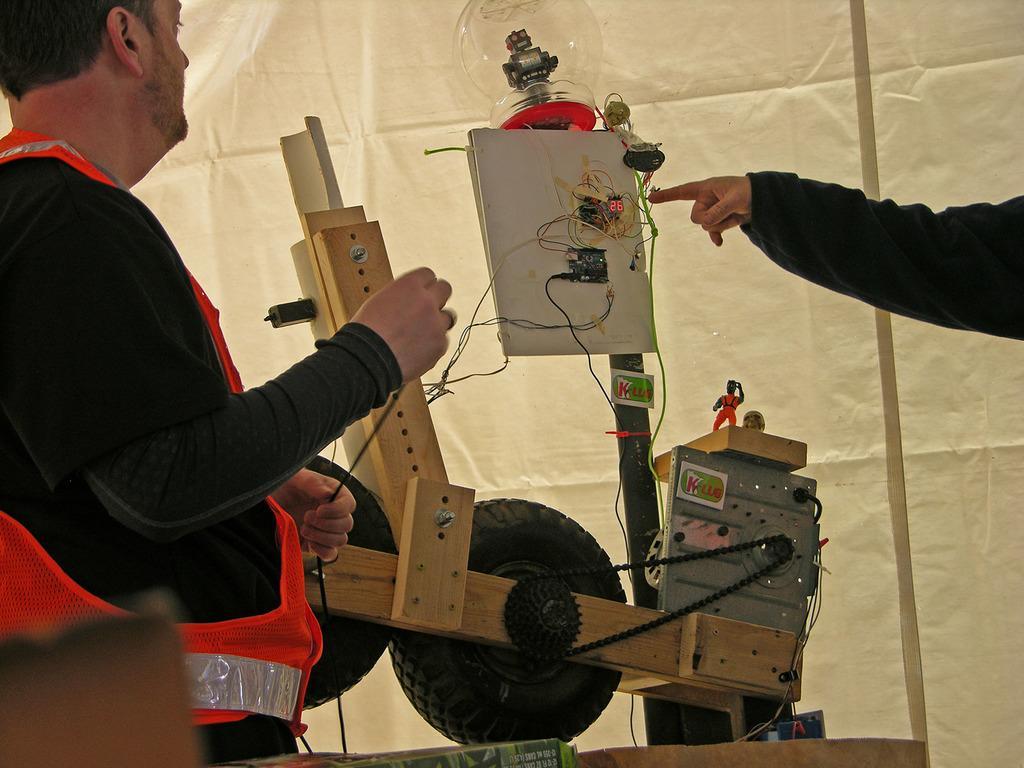In one or two sentences, can you explain what this image depicts? In the picture we can see a man standing with orange jacket and black T-shirt and making some electronic connectors with wires and in the opposite side, we can see a person's hand showing something and in the background we can see the tent curtain. 